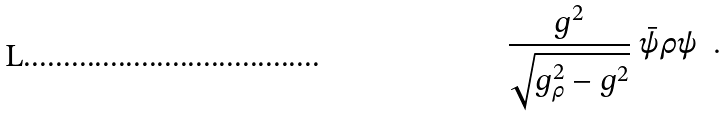<formula> <loc_0><loc_0><loc_500><loc_500>\frac { g ^ { 2 } } { \sqrt { g _ { \rho } ^ { 2 } - g ^ { 2 } } } \ \bar { \psi } \rho \psi \ \ .</formula> 